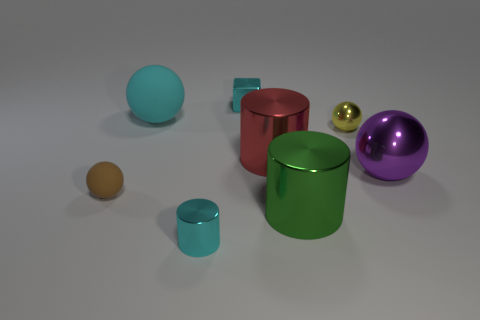Add 1 large blue metallic cylinders. How many objects exist? 9 Subtract all cubes. How many objects are left? 7 Subtract all small gray metal things. Subtract all purple balls. How many objects are left? 7 Add 2 big green cylinders. How many big green cylinders are left? 3 Add 2 tiny purple rubber cylinders. How many tiny purple rubber cylinders exist? 2 Subtract 1 green cylinders. How many objects are left? 7 